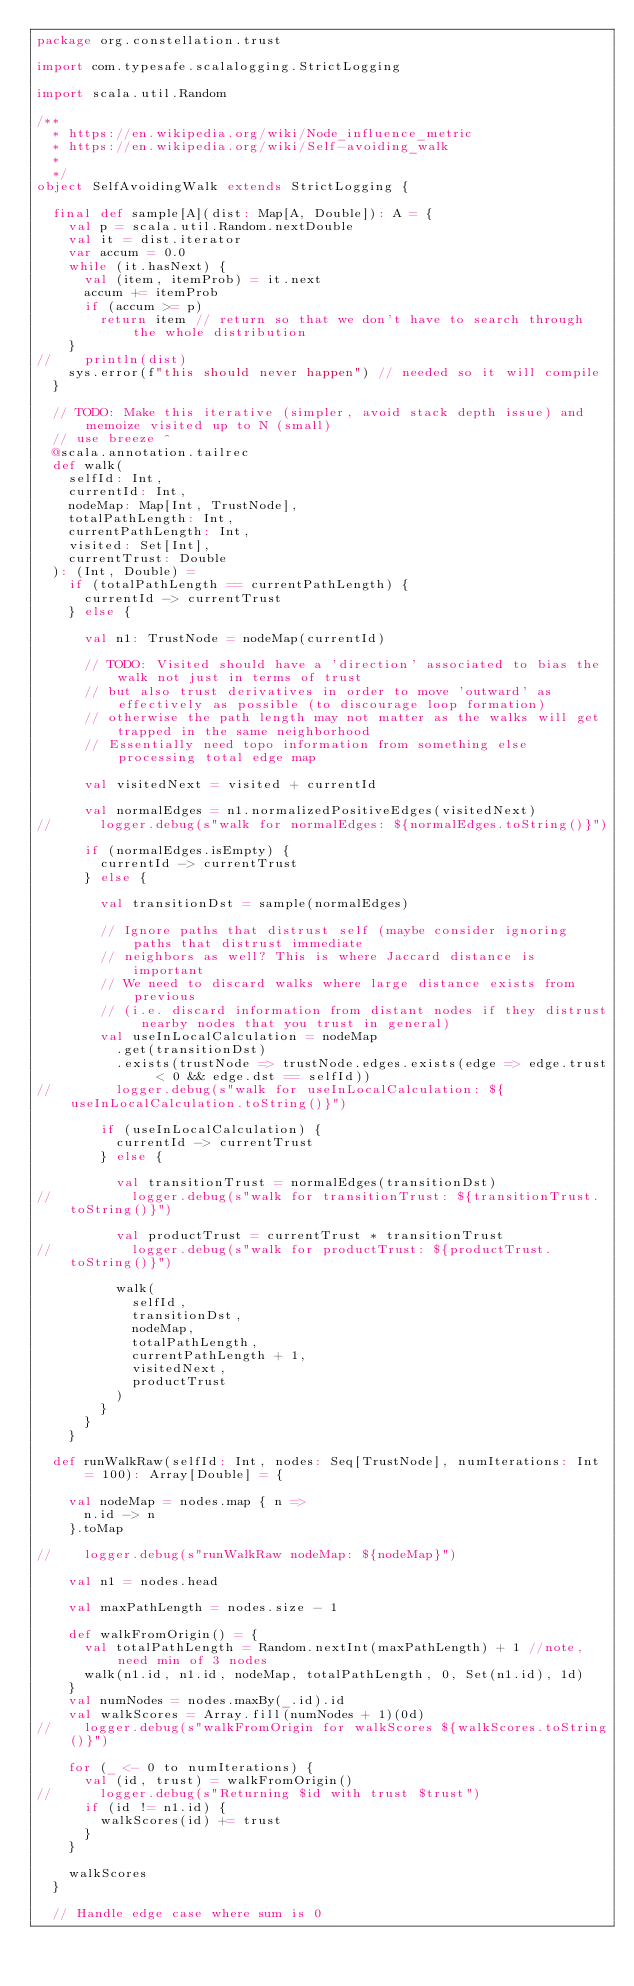<code> <loc_0><loc_0><loc_500><loc_500><_Scala_>package org.constellation.trust

import com.typesafe.scalalogging.StrictLogging

import scala.util.Random

/**
  * https://en.wikipedia.org/wiki/Node_influence_metric
  * https://en.wikipedia.org/wiki/Self-avoiding_walk
  *
  */
object SelfAvoidingWalk extends StrictLogging {

  final def sample[A](dist: Map[A, Double]): A = {
    val p = scala.util.Random.nextDouble
    val it = dist.iterator
    var accum = 0.0
    while (it.hasNext) {
      val (item, itemProb) = it.next
      accum += itemProb
      if (accum >= p)
        return item // return so that we don't have to search through the whole distribution
    }
//    println(dist)
    sys.error(f"this should never happen") // needed so it will compile
  }

  // TODO: Make this iterative (simpler, avoid stack depth issue) and memoize visited up to N (small)
  // use breeze ^
  @scala.annotation.tailrec
  def walk(
    selfId: Int,
    currentId: Int,
    nodeMap: Map[Int, TrustNode],
    totalPathLength: Int,
    currentPathLength: Int,
    visited: Set[Int],
    currentTrust: Double
  ): (Int, Double) =
    if (totalPathLength == currentPathLength) {
      currentId -> currentTrust
    } else {

      val n1: TrustNode = nodeMap(currentId)

      // TODO: Visited should have a 'direction' associated to bias the walk not just in terms of trust
      // but also trust derivatives in order to move 'outward' as effectively as possible (to discourage loop formation)
      // otherwise the path length may not matter as the walks will get trapped in the same neighborhood
      // Essentially need topo information from something else processing total edge map

      val visitedNext = visited + currentId

      val normalEdges = n1.normalizedPositiveEdges(visitedNext)
//      logger.debug(s"walk for normalEdges: ${normalEdges.toString()}")

      if (normalEdges.isEmpty) {
        currentId -> currentTrust
      } else {

        val transitionDst = sample(normalEdges)

        // Ignore paths that distrust self (maybe consider ignoring paths that distrust immediate
        // neighbors as well? This is where Jaccard distance is important
        // We need to discard walks where large distance exists from previous
        // (i.e. discard information from distant nodes if they distrust nearby nodes that you trust in general)
        val useInLocalCalculation = nodeMap
          .get(transitionDst)
          .exists(trustNode => trustNode.edges.exists(edge => edge.trust < 0 && edge.dst == selfId))
//        logger.debug(s"walk for useInLocalCalculation: ${useInLocalCalculation.toString()}")

        if (useInLocalCalculation) {
          currentId -> currentTrust
        } else {

          val transitionTrust = normalEdges(transitionDst)
//          logger.debug(s"walk for transitionTrust: ${transitionTrust.toString()}")

          val productTrust = currentTrust * transitionTrust
//          logger.debug(s"walk for productTrust: ${productTrust.toString()}")

          walk(
            selfId,
            transitionDst,
            nodeMap,
            totalPathLength,
            currentPathLength + 1,
            visitedNext,
            productTrust
          )
        }
      }
    }

  def runWalkRaw(selfId: Int, nodes: Seq[TrustNode], numIterations: Int = 100): Array[Double] = {

    val nodeMap = nodes.map { n =>
      n.id -> n
    }.toMap

//    logger.debug(s"runWalkRaw nodeMap: ${nodeMap}")

    val n1 = nodes.head

    val maxPathLength = nodes.size - 1

    def walkFromOrigin() = {
      val totalPathLength = Random.nextInt(maxPathLength) + 1 //note, need min of 3 nodes
      walk(n1.id, n1.id, nodeMap, totalPathLength, 0, Set(n1.id), 1d)
    }
    val numNodes = nodes.maxBy(_.id).id
    val walkScores = Array.fill(numNodes + 1)(0d)
//    logger.debug(s"walkFromOrigin for walkScores ${walkScores.toString()}")

    for (_ <- 0 to numIterations) {
      val (id, trust) = walkFromOrigin()
//      logger.debug(s"Returning $id with trust $trust")
      if (id != n1.id) {
        walkScores(id) += trust
      }
    }

    walkScores
  }

  // Handle edge case where sum is 0</code> 